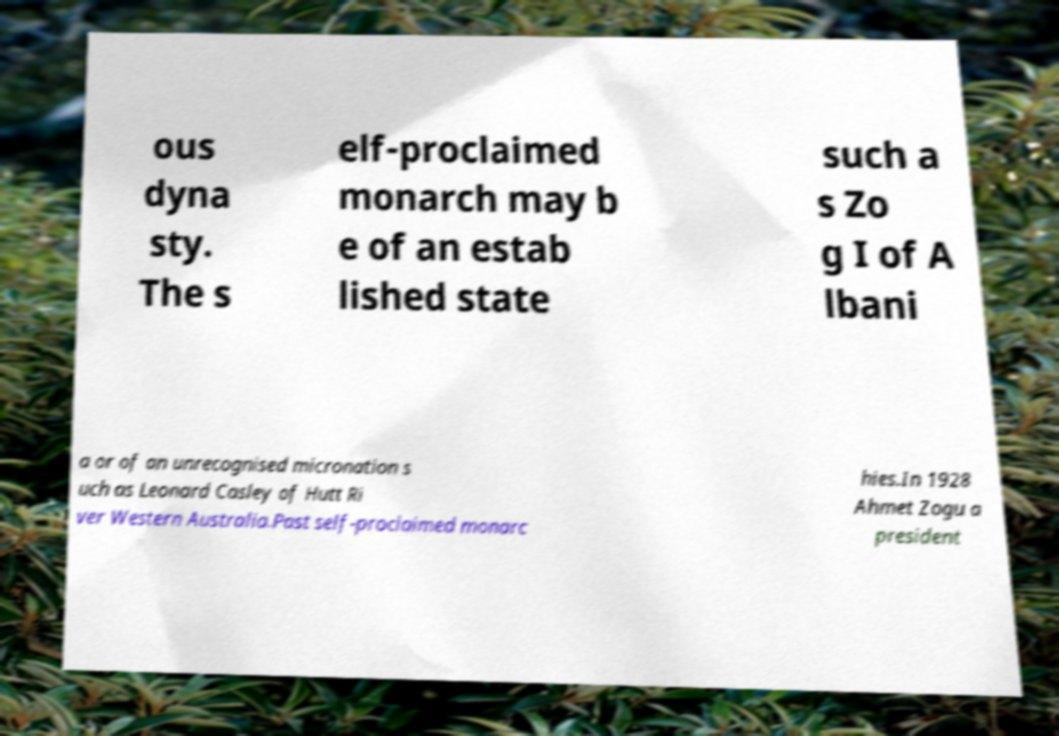There's text embedded in this image that I need extracted. Can you transcribe it verbatim? ous dyna sty. The s elf-proclaimed monarch may b e of an estab lished state such a s Zo g I of A lbani a or of an unrecognised micronation s uch as Leonard Casley of Hutt Ri ver Western Australia.Past self-proclaimed monarc hies.In 1928 Ahmet Zogu a president 